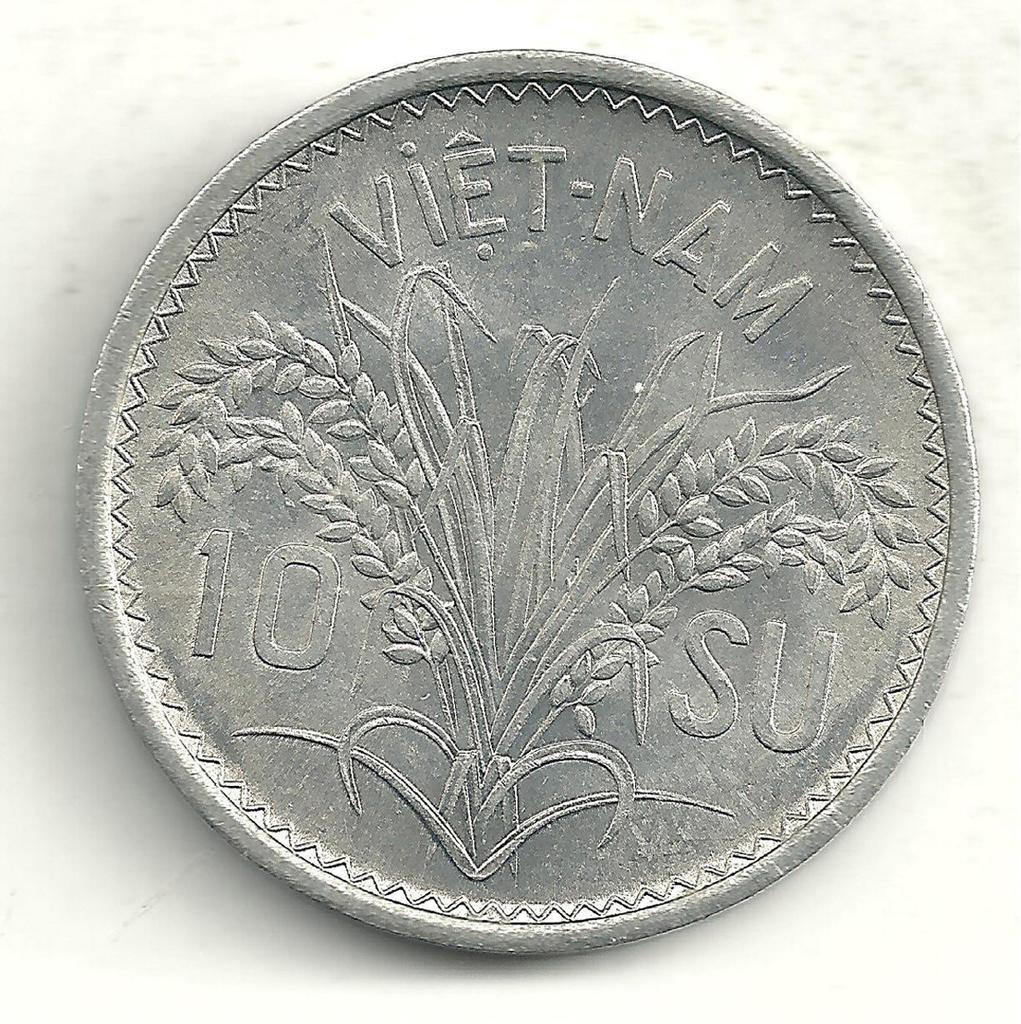What is this coin from?
Provide a succinct answer. Vietnam. What number can be seen on the coin?
Offer a very short reply. 10. 